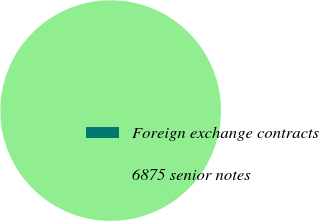Convert chart to OTSL. <chart><loc_0><loc_0><loc_500><loc_500><pie_chart><fcel>Foreign exchange contracts<fcel>6875 senior notes<nl><fcel>0.07%<fcel>99.93%<nl></chart> 